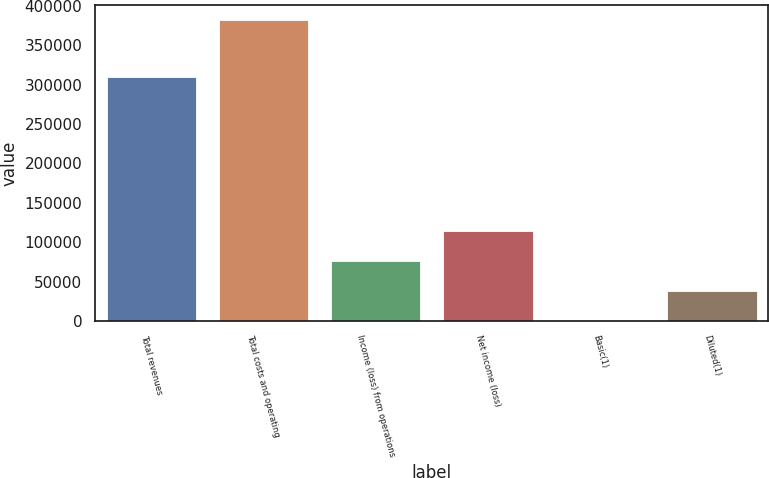Convert chart to OTSL. <chart><loc_0><loc_0><loc_500><loc_500><bar_chart><fcel>Total revenues<fcel>Total costs and operating<fcel>Income (loss) from operations<fcel>Net income (loss)<fcel>Basic(1)<fcel>Diluted(1)<nl><fcel>309612<fcel>381893<fcel>76379<fcel>114568<fcel>0.49<fcel>38189.7<nl></chart> 